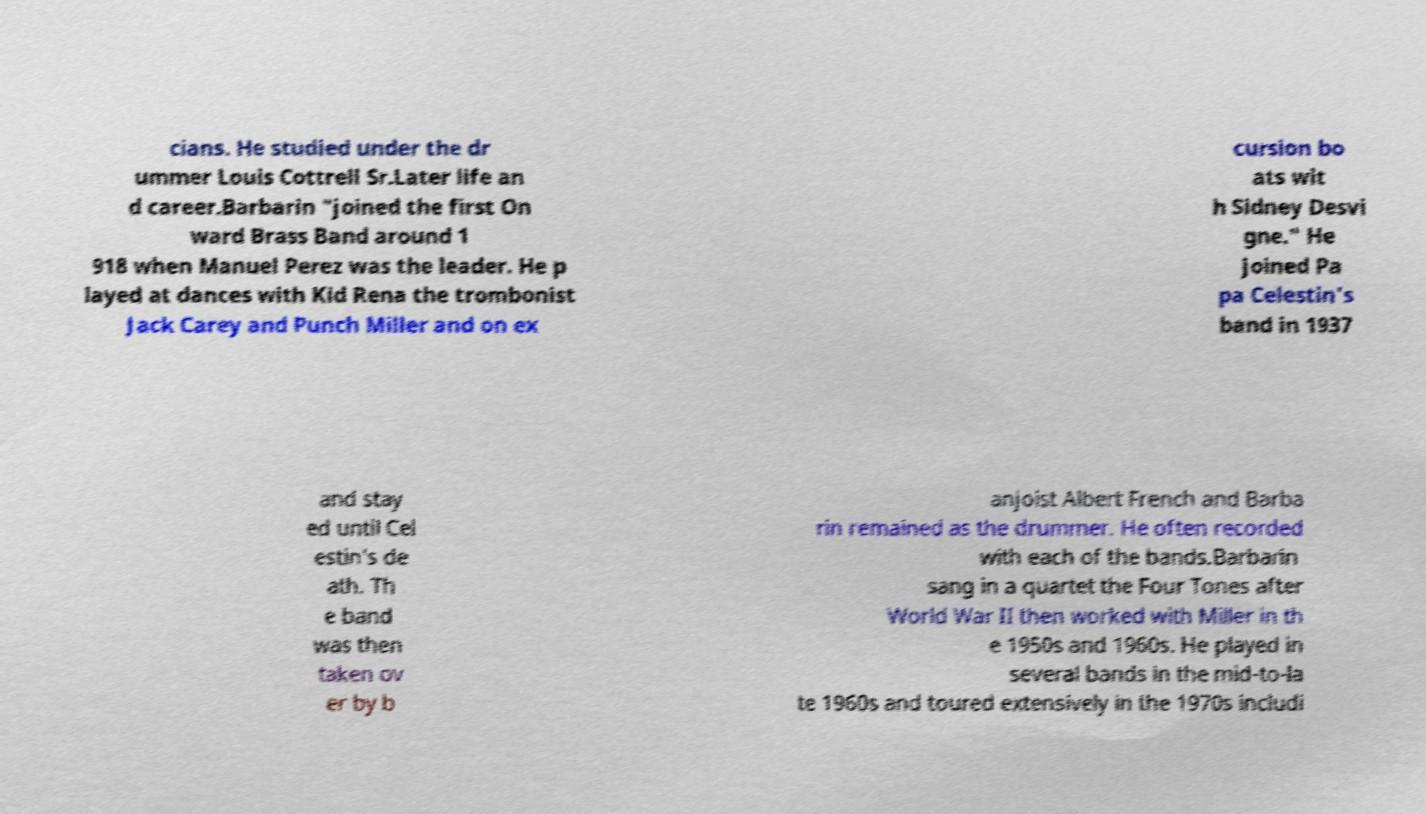I need the written content from this picture converted into text. Can you do that? cians. He studied under the dr ummer Louis Cottrell Sr.Later life an d career.Barbarin "joined the first On ward Brass Band around 1 918 when Manuel Perez was the leader. He p layed at dances with Kid Rena the trombonist Jack Carey and Punch Miller and on ex cursion bo ats wit h Sidney Desvi gne." He joined Pa pa Celestin's band in 1937 and stay ed until Cel estin's de ath. Th e band was then taken ov er by b anjoist Albert French and Barba rin remained as the drummer. He often recorded with each of the bands.Barbarin sang in a quartet the Four Tones after World War II then worked with Miller in th e 1950s and 1960s. He played in several bands in the mid-to-la te 1960s and toured extensively in the 1970s includi 